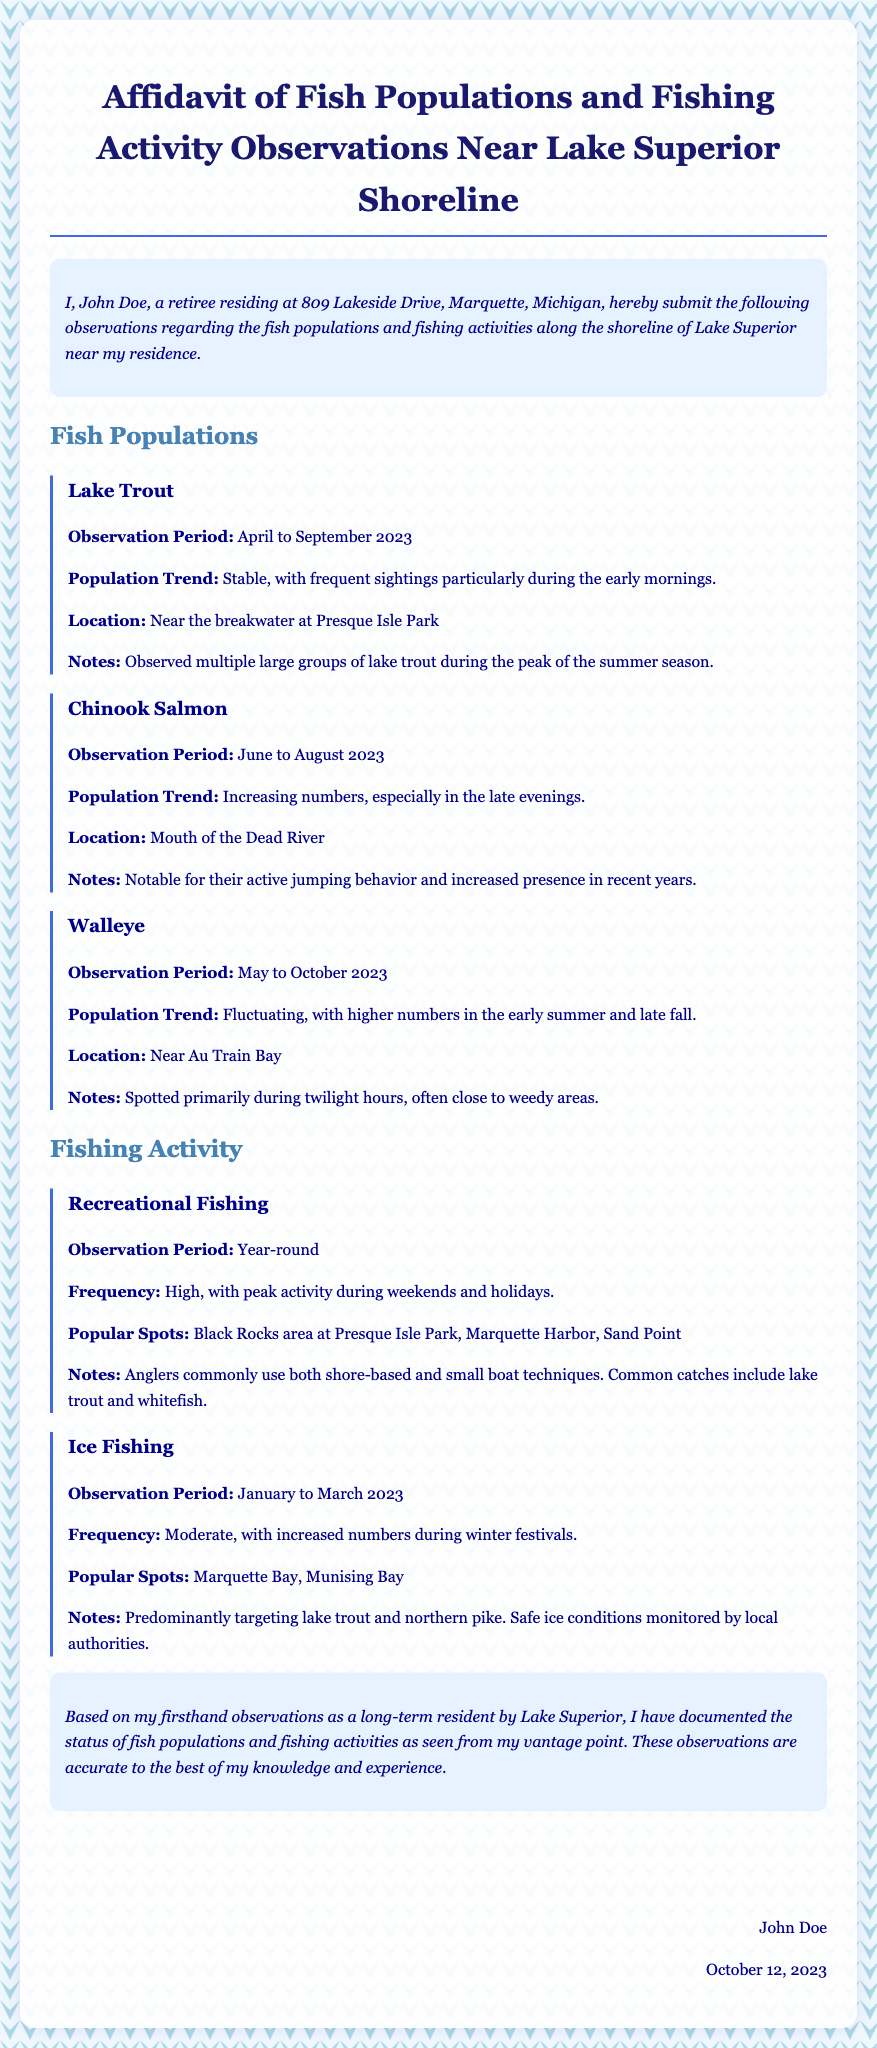What is the name of the person submitting the affidavit? The document states that the individual submitting the affidavit is John Doe.
Answer: John Doe What is the observation period for Lake Trout? The observation period mentioned for Lake Trout is April to September 2023.
Answer: April to September 2023 Where were Chinook Salmon primarily observed? The document indicates that Chinook Salmon were observed at the Mouth of the Dead River.
Answer: Mouth of the Dead River What is the population trend of Walleye? According to the affidavit, the population trend of Walleye is fluctuating.
Answer: Fluctuating Which fishing activity has a high frequency during weekends? The affidavit specifies that recreational fishing has a high frequency during weekends and holidays.
Answer: Recreational Fishing What is the observation period for Ice Fishing? The observation period for Ice Fishing stated in the document is January to March 2023.
Answer: January to March 2023 What does the author conclude about their observations? The author concludes that the observations are accurate to the best of their knowledge and experience.
Answer: Accurate to the best of my knowledge What is the signature date of the affidavit? The affidavit was signed on October 12, 2023, as indicated by the date near the signature.
Answer: October 12, 2023 What notable behavior was observed in Chinook Salmon? The affidavit notes that Chinook Salmon were notable for their active jumping behavior.
Answer: Active jumping behavior 